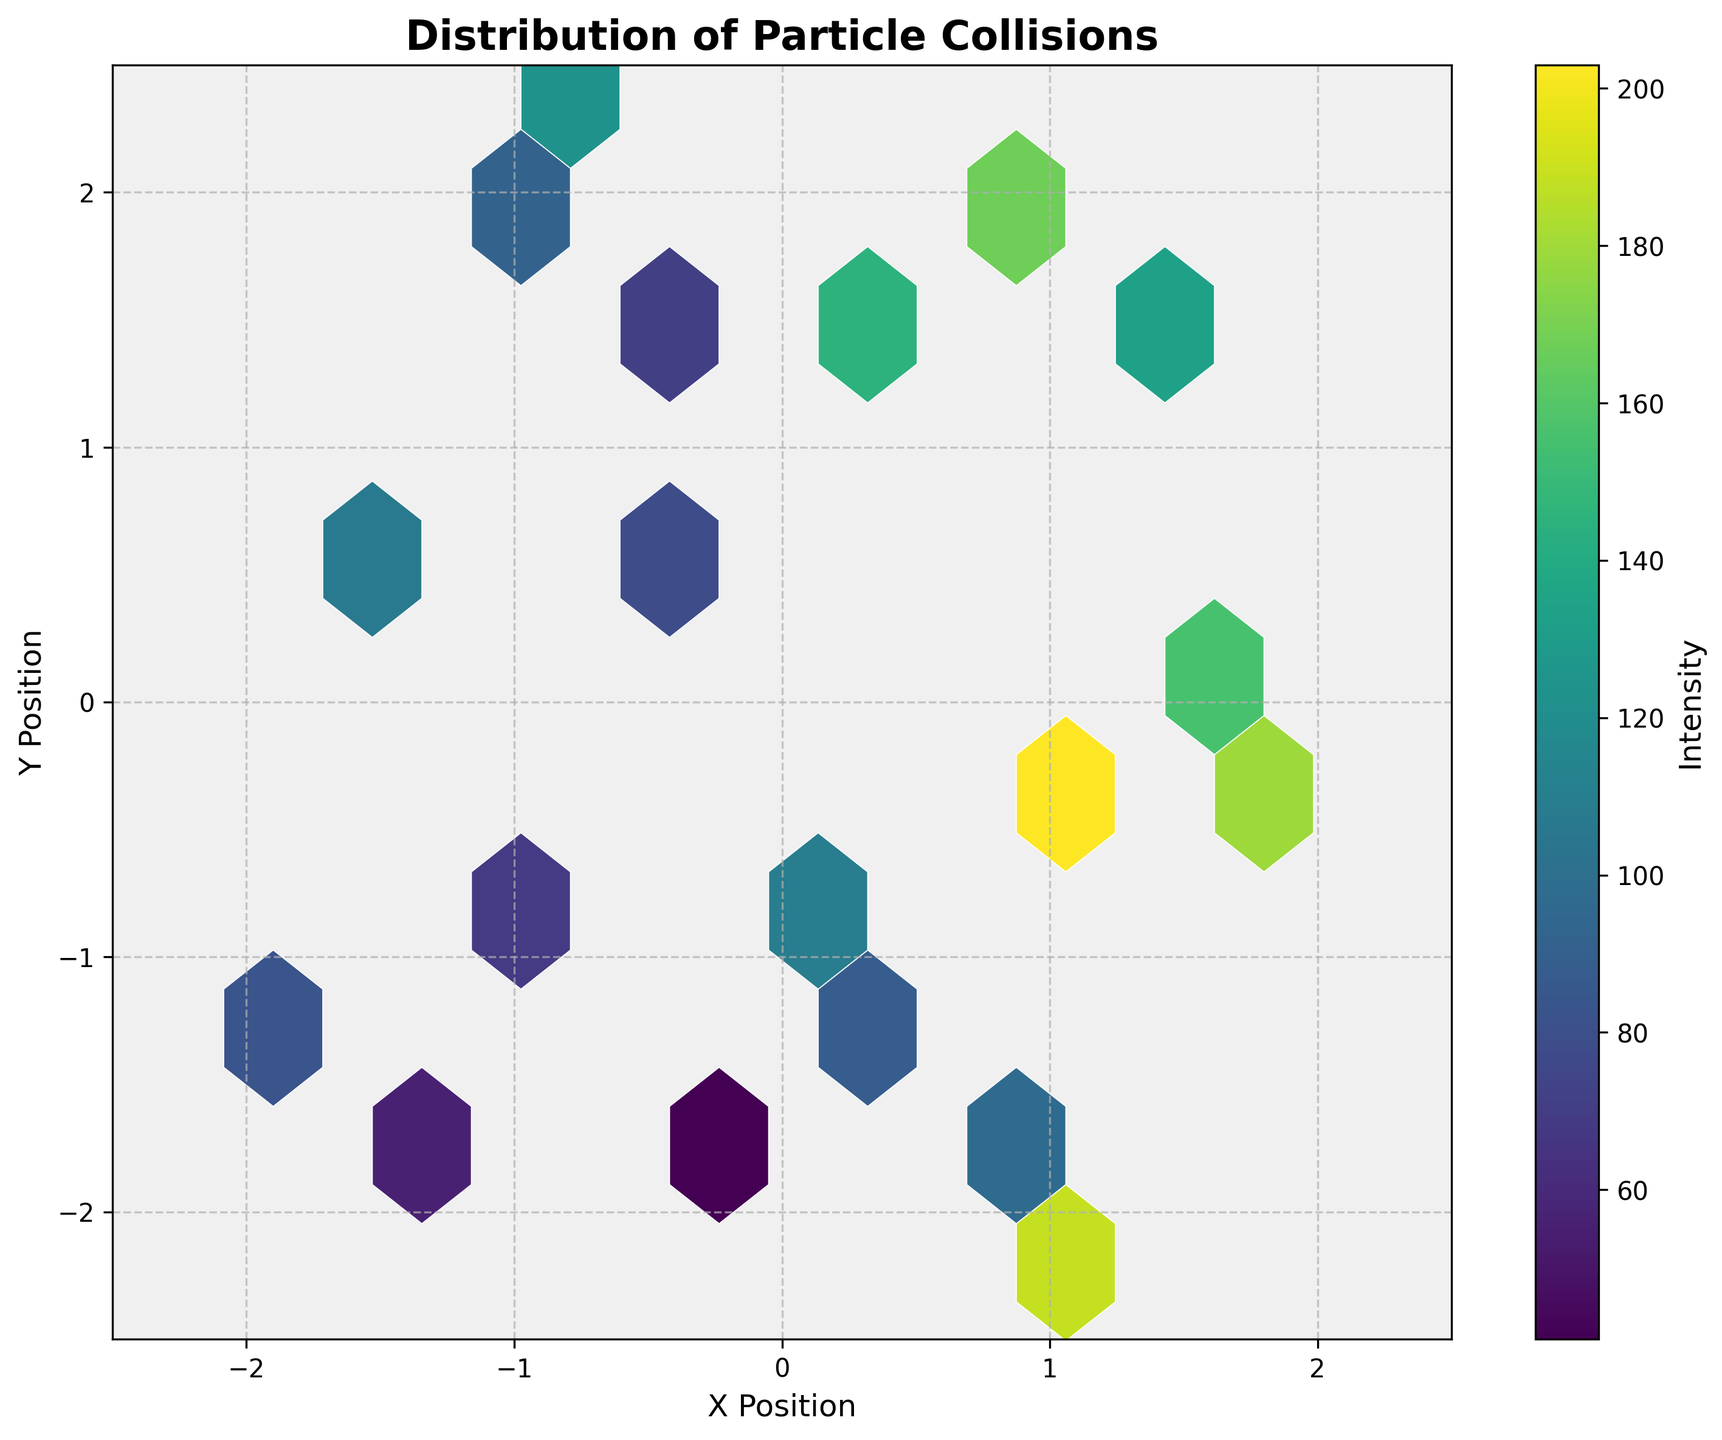What is the title of the plot? The title of the plot is usually located at the top of the figure. In this case, the title reads "Distribution of Particle Collisions."
Answer: Distribution of Particle Collisions What do the x and y axes represent in the plot? The labels for the x and y axes are "X Position" and "Y Position," respectively.
Answer: X Position and Y Position What does the color represent in this plot? In a hexbin plot, the color typically reflects the intensity of particle collisions, which is indicated by the color bar on the right side of the figure.
Answer: Intensity What is the shape and orientation of the hexagons used in the plot? The hexagons in a hexbin plot are always hexagonal in shape and are oriented with a flat top and bottom.
Answer: Hexagonal, flat top and bottom Is there a color bar in the figure, and what does it indicate? Yes, there is a color bar on the right side of the figure. It indicates the intensity of particle collisions.
Answer: Yes, it indicates the intensity What is the range of values for the x and y axes? The range of values for both the x and y axes spans from -2.5 to 2.5, as indicated by the axis limits and ticks.
Answer: -2.5 to 2.5 Which area in the plot shows the highest intensity of particle collisions? The area with the highest intensity of particle collisions can be identified by the darkest color, which appears around (1.1, -0.3).
Answer: Around (1.1, -0.3) What is the intensity at the center of the plot? You can determine the intensity at the center of the plot by looking at the color of the hexagon around the coordinates (0, 0). However, without the figure, this question remains unanswerable explicitly.
Answer: Cannot be determined explicitly Are the particle collisions evenly distributed across the plot? By observing the color and density of the hexagons, it appears the particle collisions are not evenly distributed. There are regions with higher and lower intensities.
Answer: No What is the approximate intensity value at (0.2, 1.5)? By looking at the color of the hexagon around this point and referring to the color bar, the approximate intensity value can be read. In this case, it is around 145.
Answer: 145 